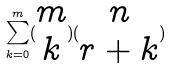Convert formula to latex. <formula><loc_0><loc_0><loc_500><loc_500>\sum _ { k = 0 } ^ { m } ( \begin{matrix} m \\ k \end{matrix} ) ( \begin{matrix} n \\ r + k \end{matrix} )</formula> 